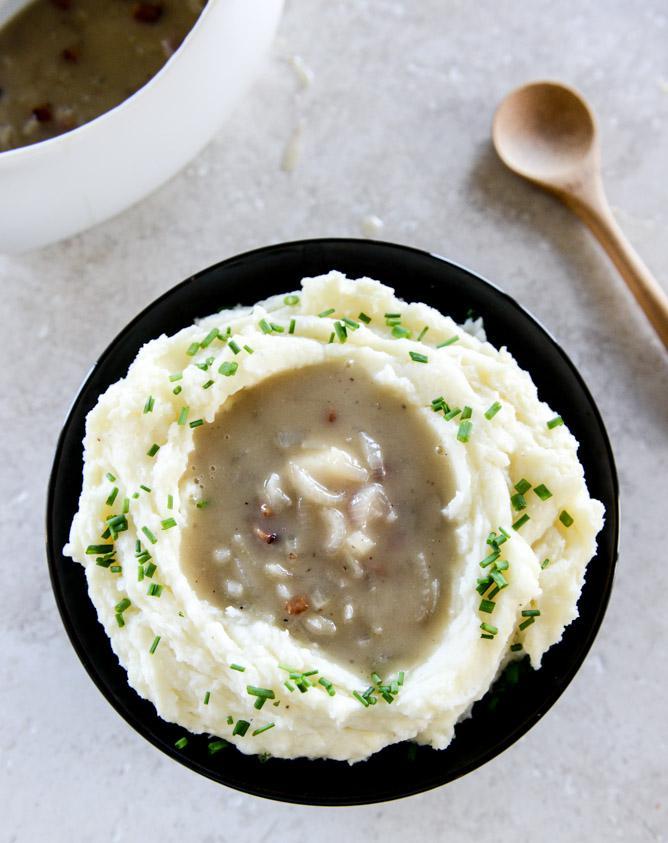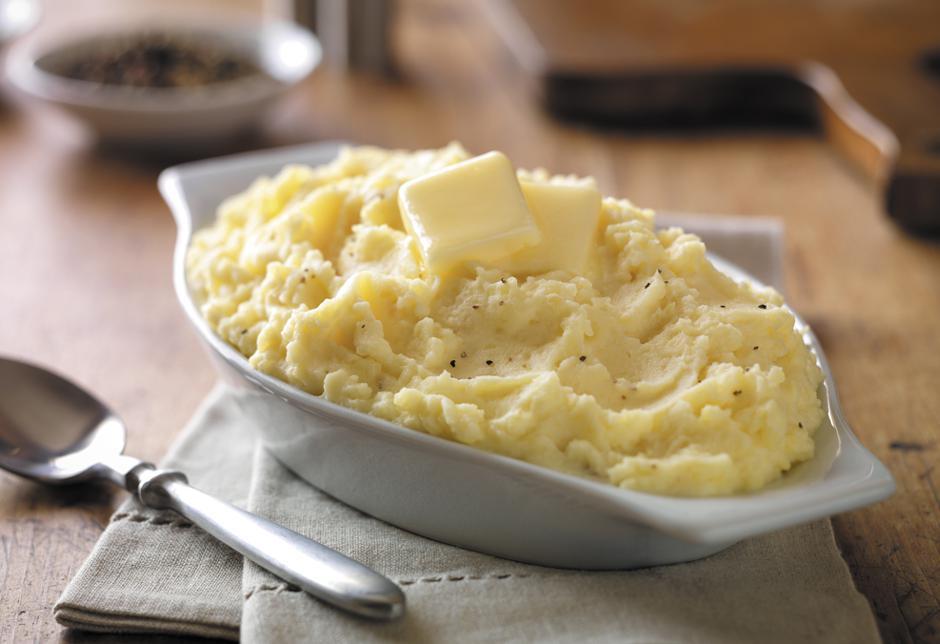The first image is the image on the left, the second image is the image on the right. Considering the images on both sides, is "The mashed potatoes on the right have a spoon handle visibly sticking out of them" valid? Answer yes or no. No. The first image is the image on the left, the second image is the image on the right. Given the left and right images, does the statement "There is a wooden spoon in the mashed potatos" hold true? Answer yes or no. No. 